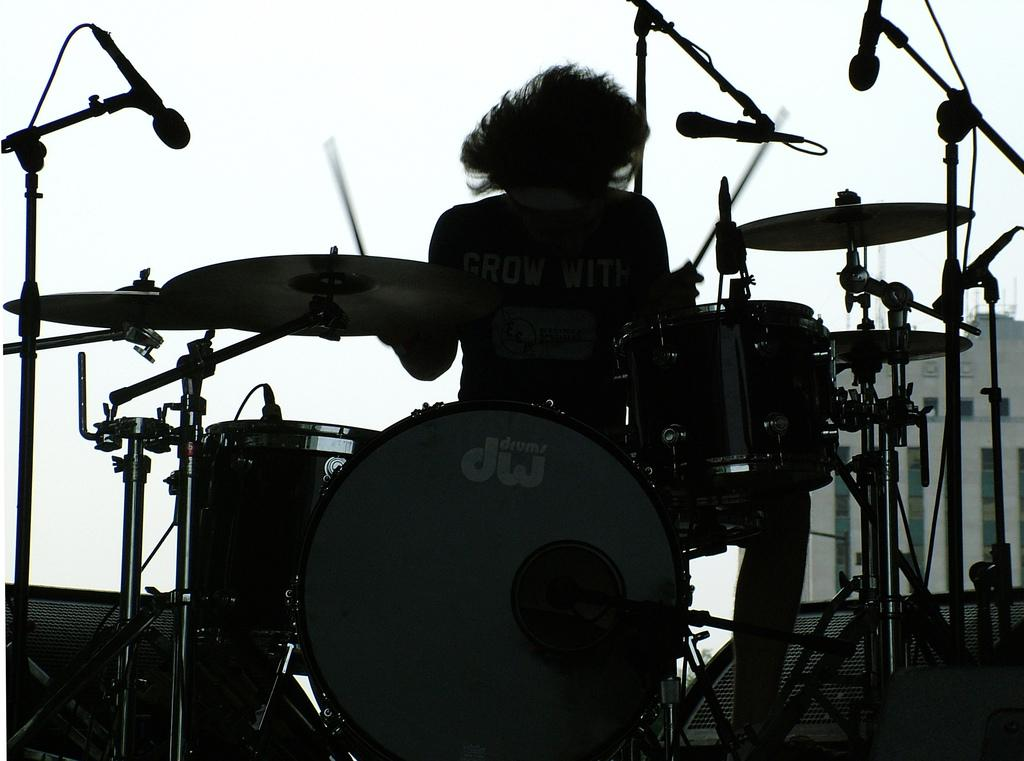What is the main subject of the image? There is a person in the image. What is the person doing in the image? The person is playing drums. What type of suit is the person wearing while playing the drums in the image? There is no suit visible in the image. The person is not wearing a suit, and the image does not depict a farm. 